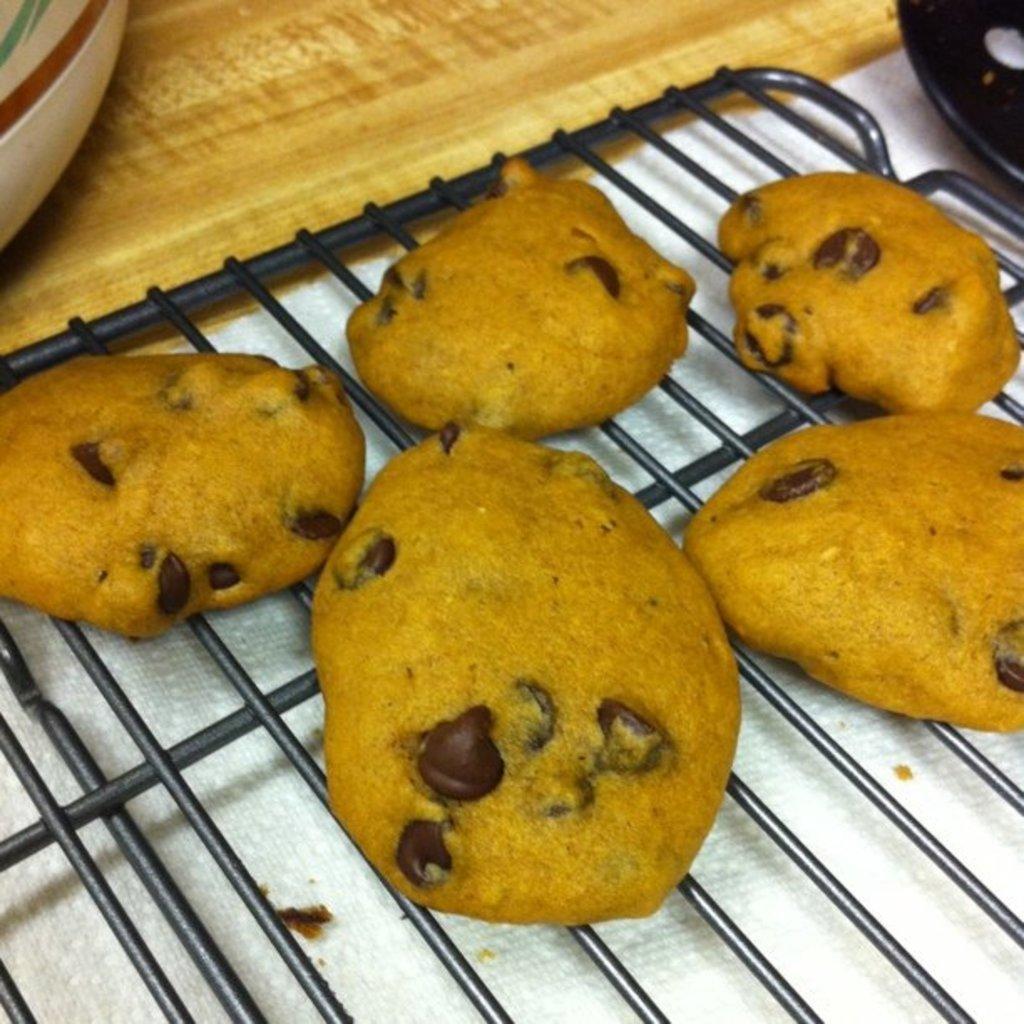Could you give a brief overview of what you see in this image? In this picture I can observe some food placed on the black color grill. The food is in yellow color. The grill is placed on the cream color table. 